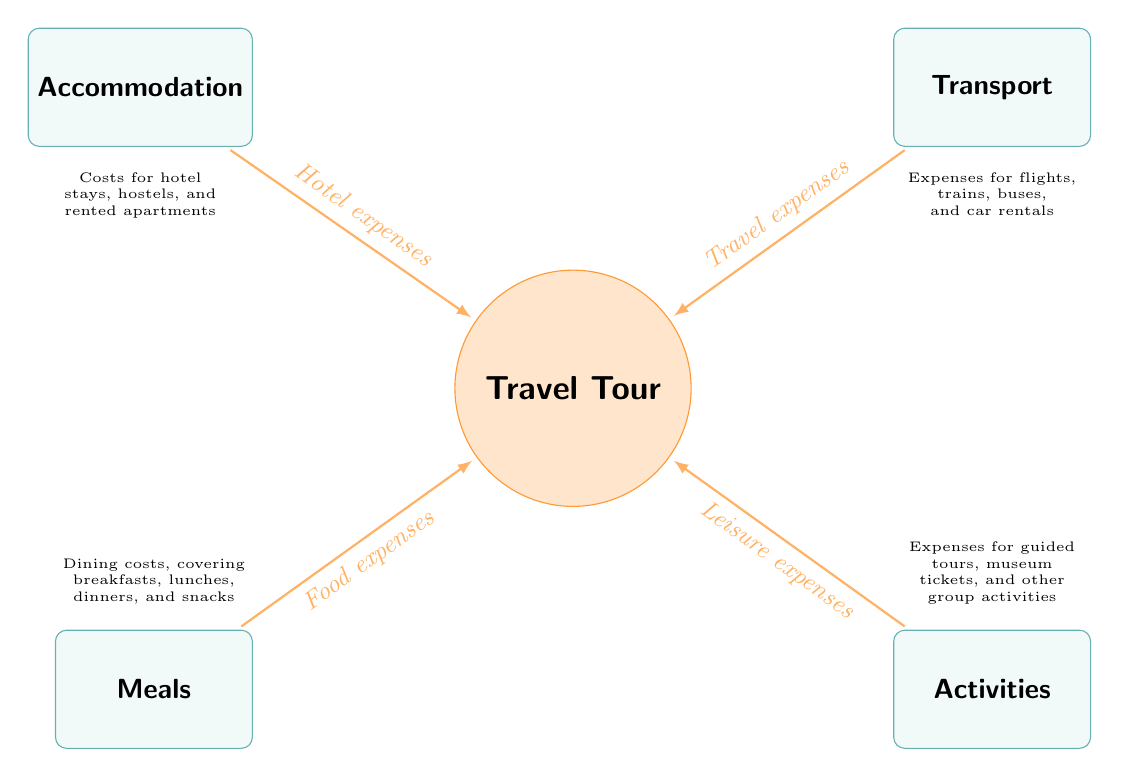What are the four main expense categories in the tour? The diagram displays four main expense categories associated with group travel: Accommodation, Transport, Meals, and Activities, which are all connected to the main node of the Travel Tour.
Answer: Accommodation, Transport, Meals, Activities What type of expenses are associated with the Accommodation node? The Accommodation node is labeled with "Hotel expenses," indicating that it summarizes costs related to lodging during the tour, such as hotel stays or hostels.
Answer: Hotel expenses How many nodes are present in the diagram? The main node is "Travel Tour," and there are four additional nodes representing expense categories, making a total of five nodes in the diagram.
Answer: 5 What is the relationship between Transport and the Travel Tour? An arrow connects the Transport node to the Travel Tour node, with a label stating "Travel expenses," meaning that transportation costs contribute to the overall travel tour expenses.
Answer: Travel expenses What kind of expenses are covered under the Meals node? The Meals node is associated with "Food expenses," which encompasses all dining-related costs including breakfasts, lunches, dinners, and snacks throughout the trip.
Answer: Food expenses Which expense category would likely include costs for guided tours? Guided tours fall under the Activities node, as this node is labeled with "Leisure expenses" that account for expenses such as touring and entry fees to attractions.
Answer: Activities What type of transport costs are included in the diagram? The Transport node includes expenses related to different modes of transport such as flights, trains, buses, and car rentals, as indicated in the details section of the diagram.
Answer: Flights, trains, buses, car rentals Which expense category is positioned at the bottom left of the diagram? The bottom left position of the diagram is occupied by the Meals node, which specifically addresses dining costs incurred during the travel tour.
Answer: Meals What is indicated by the arrow flowing from Activities to Travel Tour? The arrow signifies that Leisure expenses from the Activities category contribute to the overall expenses associated with the Travel Tour.
Answer: Leisure expenses 